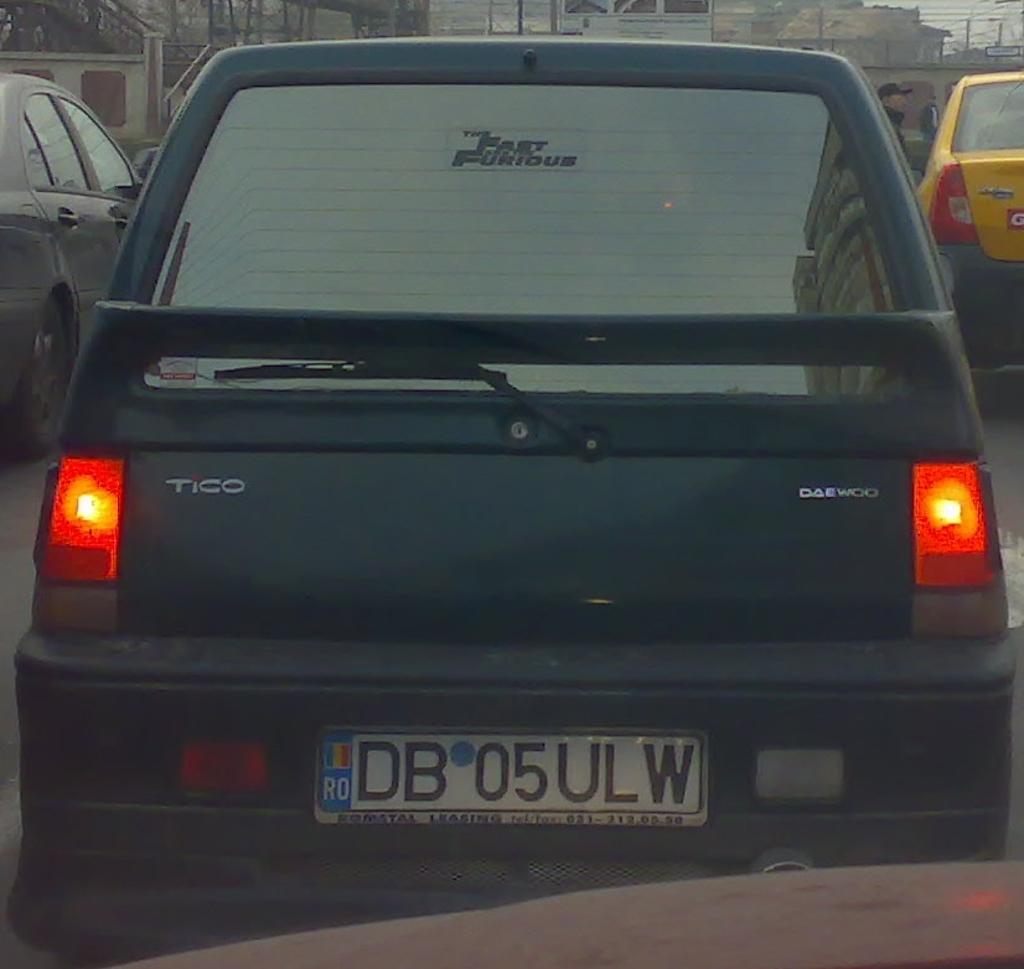Provide a one-sentence caption for the provided image. The back of a tico that is sitting in traffic with brake lights on. 